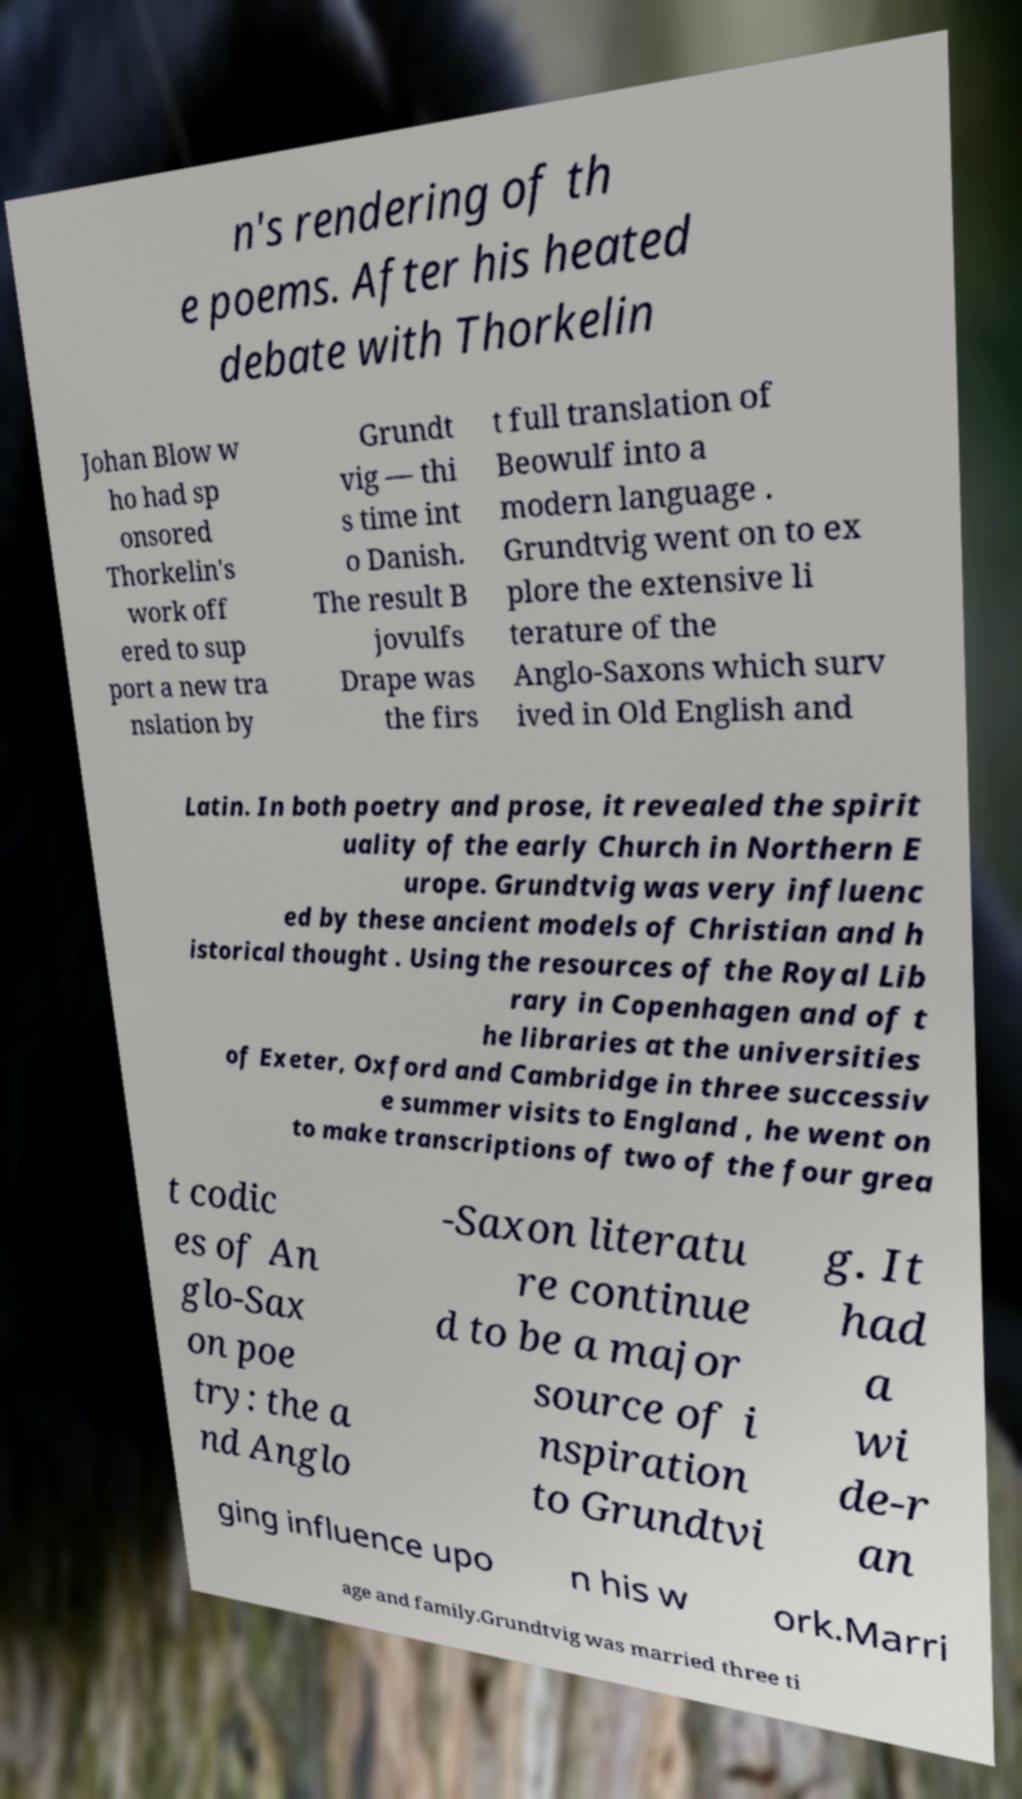Can you read and provide the text displayed in the image?This photo seems to have some interesting text. Can you extract and type it out for me? n's rendering of th e poems. After his heated debate with Thorkelin Johan Blow w ho had sp onsored Thorkelin's work off ered to sup port a new tra nslation by Grundt vig — thi s time int o Danish. The result B jovulfs Drape was the firs t full translation of Beowulf into a modern language . Grundtvig went on to ex plore the extensive li terature of the Anglo-Saxons which surv ived in Old English and Latin. In both poetry and prose, it revealed the spirit uality of the early Church in Northern E urope. Grundtvig was very influenc ed by these ancient models of Christian and h istorical thought . Using the resources of the Royal Lib rary in Copenhagen and of t he libraries at the universities of Exeter, Oxford and Cambridge in three successiv e summer visits to England , he went on to make transcriptions of two of the four grea t codic es of An glo-Sax on poe try: the a nd Anglo -Saxon literatu re continue d to be a major source of i nspiration to Grundtvi g. It had a wi de-r an ging influence upo n his w ork.Marri age and family.Grundtvig was married three ti 